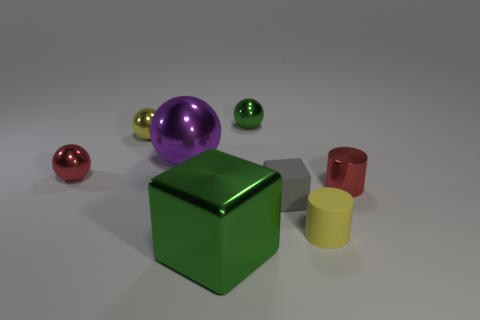Is the number of cyan cylinders less than the number of big purple metallic spheres?
Your answer should be very brief. Yes. Is the size of the red shiny object right of the small red sphere the same as the yellow object that is to the left of the small green ball?
Ensure brevity in your answer.  Yes. How many things are either big red cylinders or yellow matte objects?
Your answer should be very brief. 1. What size is the green thing that is behind the large purple metal thing?
Offer a terse response. Small. How many tiny gray matte blocks are to the left of the green object behind the tiny red metallic sphere in front of the tiny yellow shiny object?
Offer a very short reply. 0. Is the color of the shiny cube the same as the large sphere?
Your answer should be compact. No. What number of metallic things are both behind the tiny red ball and in front of the green metal ball?
Give a very brief answer. 2. There is a tiny rubber object behind the tiny yellow matte object; what is its shape?
Provide a succinct answer. Cube. Are there fewer big shiny things that are on the left side of the small yellow shiny object than green objects behind the big cube?
Provide a short and direct response. Yes. Are the yellow cylinder that is in front of the yellow shiny object and the big thing that is in front of the large purple sphere made of the same material?
Make the answer very short. No. 